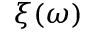Convert formula to latex. <formula><loc_0><loc_0><loc_500><loc_500>\xi ( \omega )</formula> 